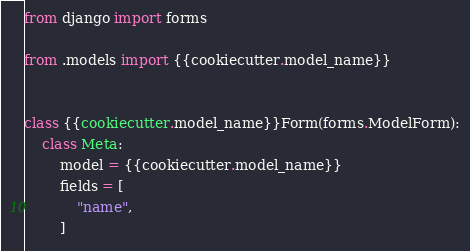Convert code to text. <code><loc_0><loc_0><loc_500><loc_500><_Python_>from django import forms

from .models import {{cookiecutter.model_name}}


class {{cookiecutter.model_name}}Form(forms.ModelForm):
    class Meta:
        model = {{cookiecutter.model_name}}
        fields = [
            "name",
        ]
</code> 